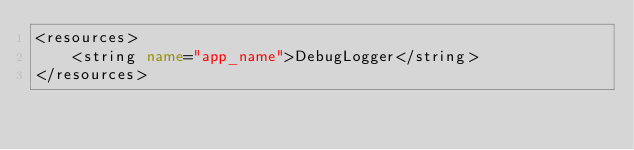Convert code to text. <code><loc_0><loc_0><loc_500><loc_500><_XML_><resources>
    <string name="app_name">DebugLogger</string>
</resources></code> 